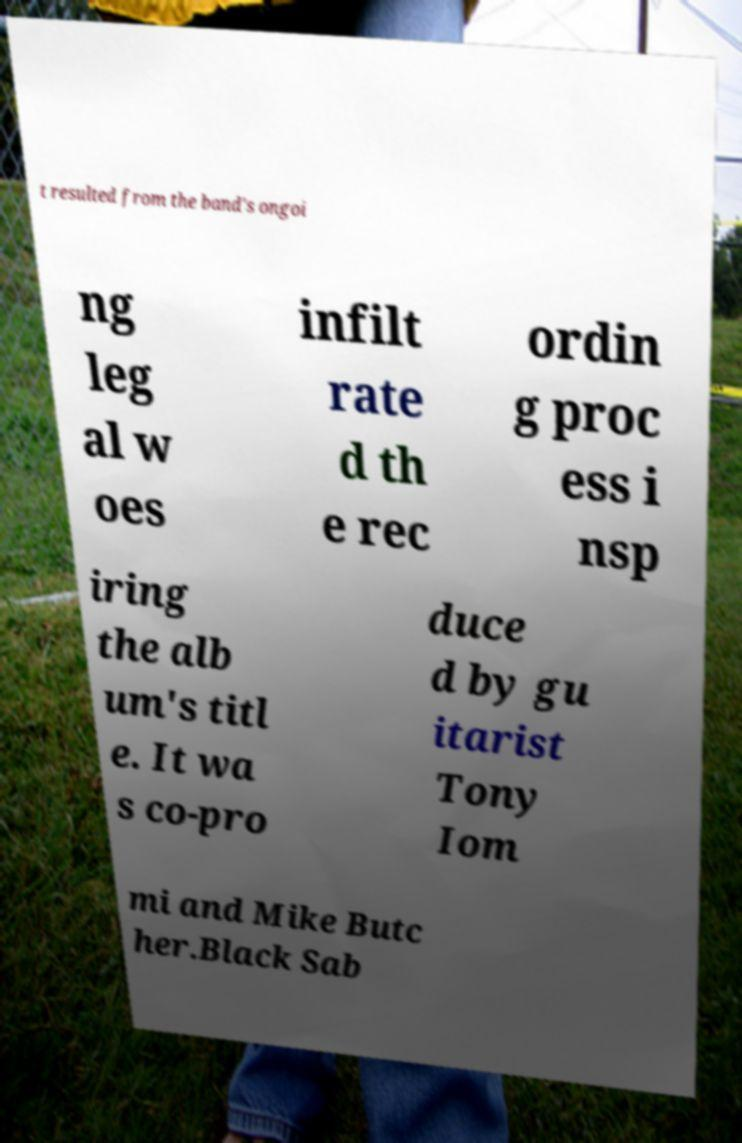Could you assist in decoding the text presented in this image and type it out clearly? t resulted from the band's ongoi ng leg al w oes infilt rate d th e rec ordin g proc ess i nsp iring the alb um's titl e. It wa s co-pro duce d by gu itarist Tony Iom mi and Mike Butc her.Black Sab 